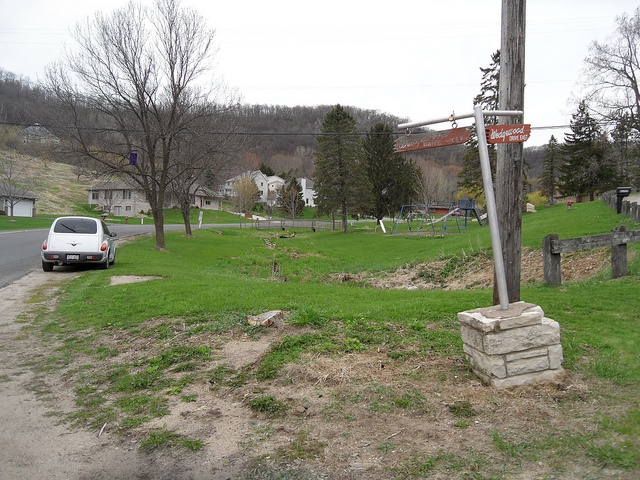Describe the objects in this image and their specific colors. I can see a car in white, lightgray, gray, black, and darkgray tones in this image. 